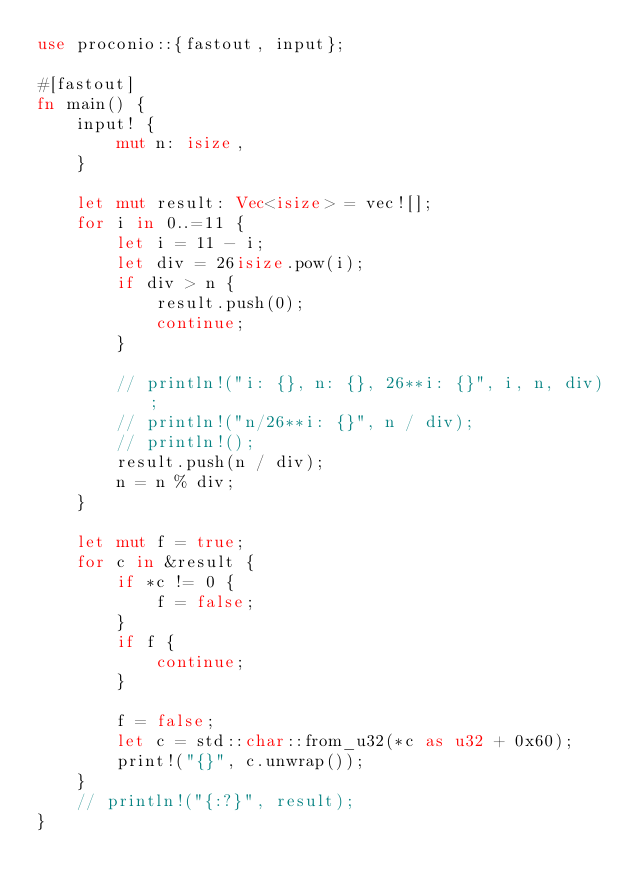Convert code to text. <code><loc_0><loc_0><loc_500><loc_500><_Rust_>use proconio::{fastout, input};

#[fastout]
fn main() {
    input! {
        mut n: isize,
    }

    let mut result: Vec<isize> = vec![];
    for i in 0..=11 {
        let i = 11 - i;
        let div = 26isize.pow(i);
        if div > n {
            result.push(0);
            continue;
        }

        // println!("i: {}, n: {}, 26**i: {}", i, n, div);
        // println!("n/26**i: {}", n / div);
        // println!();
        result.push(n / div);
        n = n % div;
    }

    let mut f = true;
    for c in &result {
        if *c != 0 {
            f = false;
        }
        if f {
            continue;
        }

        f = false;
        let c = std::char::from_u32(*c as u32 + 0x60);
        print!("{}", c.unwrap());
    }
    // println!("{:?}", result);
}
</code> 